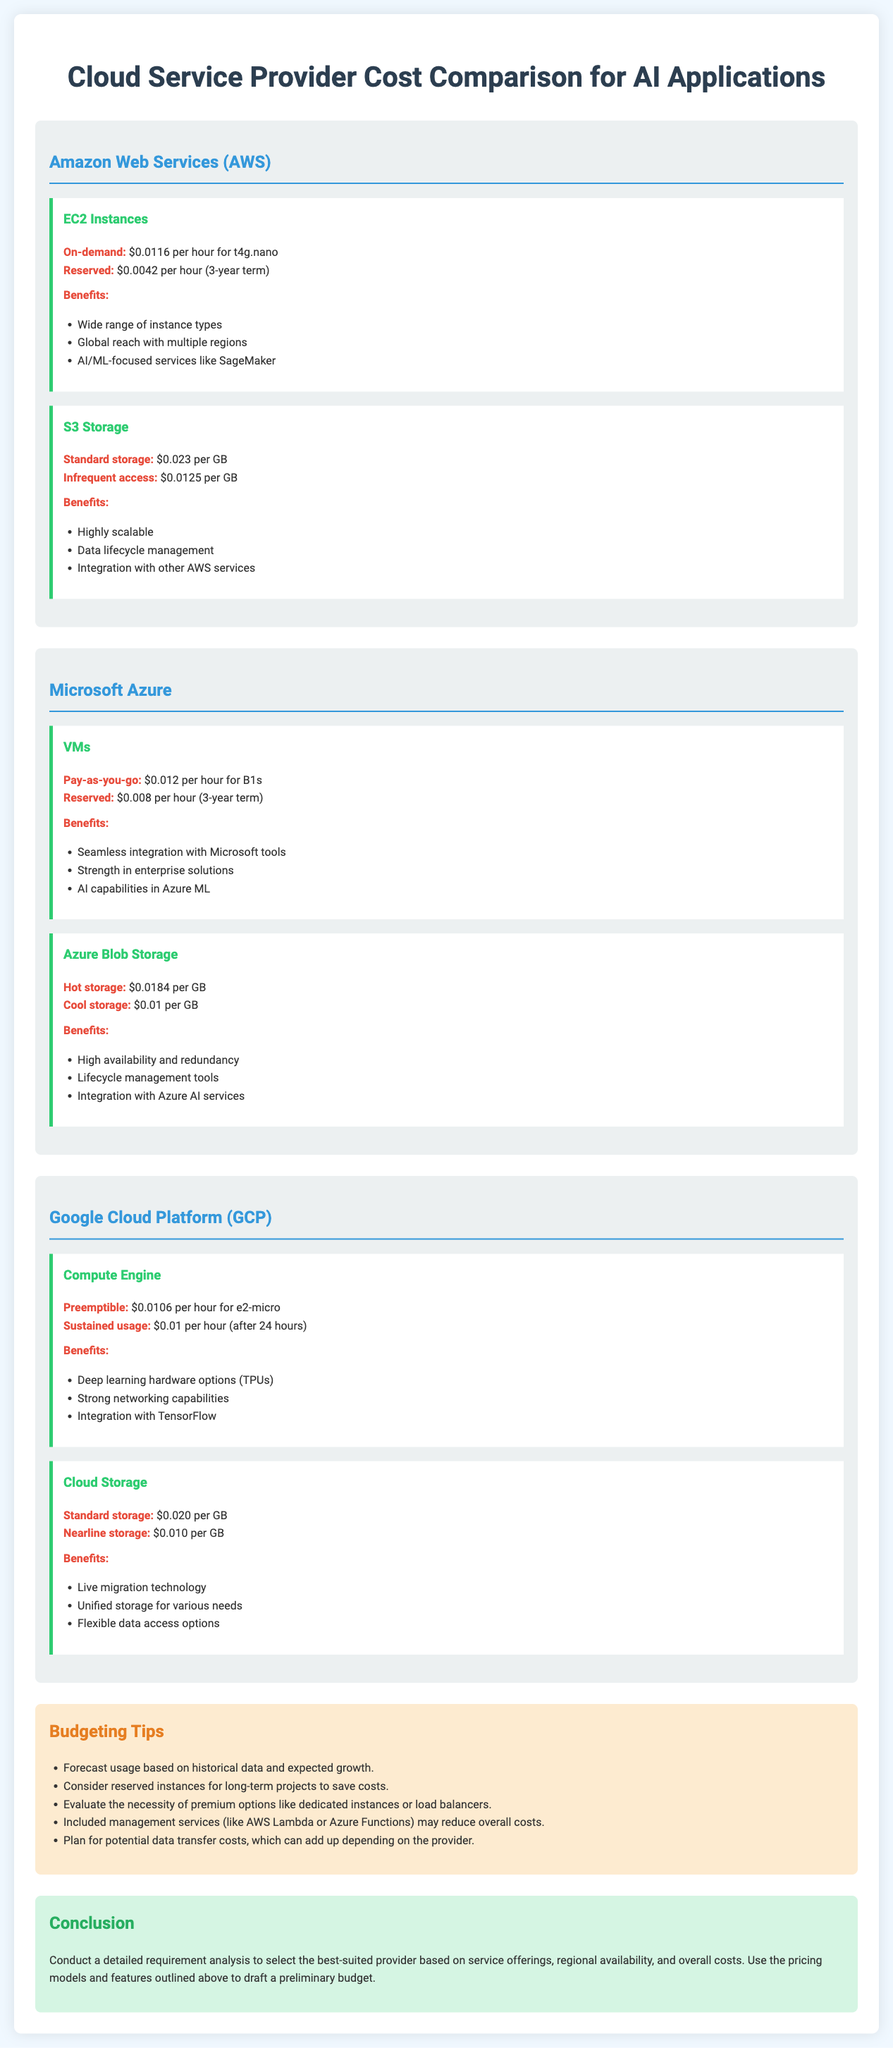what is the on-demand price for AWS EC2 t4g.nano? The on-demand price is specified in the document under AWS EC2 Instances.
Answer: $0.0116 per hour what is the storage cost for Azure Blob Cool storage? The cost for Azure Blob Cool storage is listed under the Azure Blob Storage section.
Answer: $0.01 per GB how much does GCP's Preemptible e2-micro cost per hour? The cost is mentioned in the GCP Compute Engine section, providing specific pricing details.
Answer: $0.0106 per hour what is one benefit of using AWS S3 Standard storage? The benefits of AWS S3 Standard storage are provided in a list, highlighting its advantages.
Answer: Highly scalable what is the reserved price for Microsoft Azure VMs for a 3-year term? The reserved price is given in the Azure VM pricing section, indicating long-term costs.
Answer: $0.008 per hour which provider offers deep learning hardware options like TPUs? The document specifies the distinctive features offered by the various providers, identifying unique offerings.
Answer: Google Cloud Platform what is a budgeting tip mentioned in the document? Tips for budgeting are included in a dedicated section, specifically crafted to assist with cost management.
Answer: Forecast usage based on historical data and expected growth what is the name of the service offering under GCP for data storage? This is identified in the GCP section where various storage services are listed, indicating specific service names.
Answer: Cloud Storage what color is the background of the conclusion section? The document describes the styling elements, including color choices for different sections.
Answer: Light green 